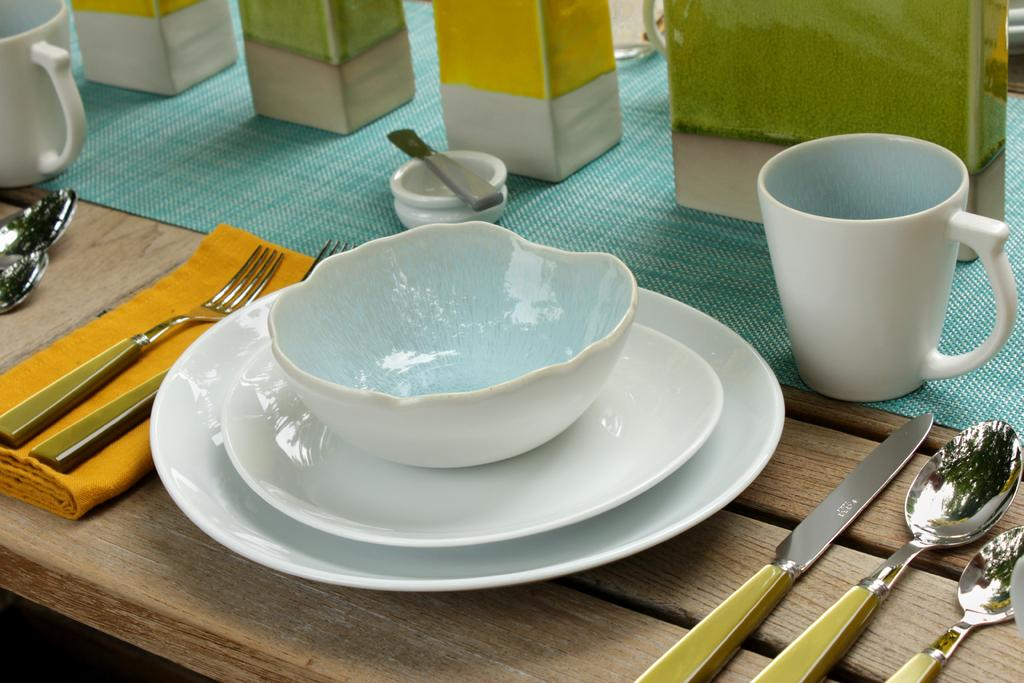What type of container is present in the image? There is a bowl in the image. What other tableware can be seen in the image? There are plates, a mug, a spoon, and a knife in the image. Where are these objects located? All objects are on a table. How many cattle are present in the image? There are no cattle present in the image. What type of mouth is visible in the image? There is no mouth visible in the image. 